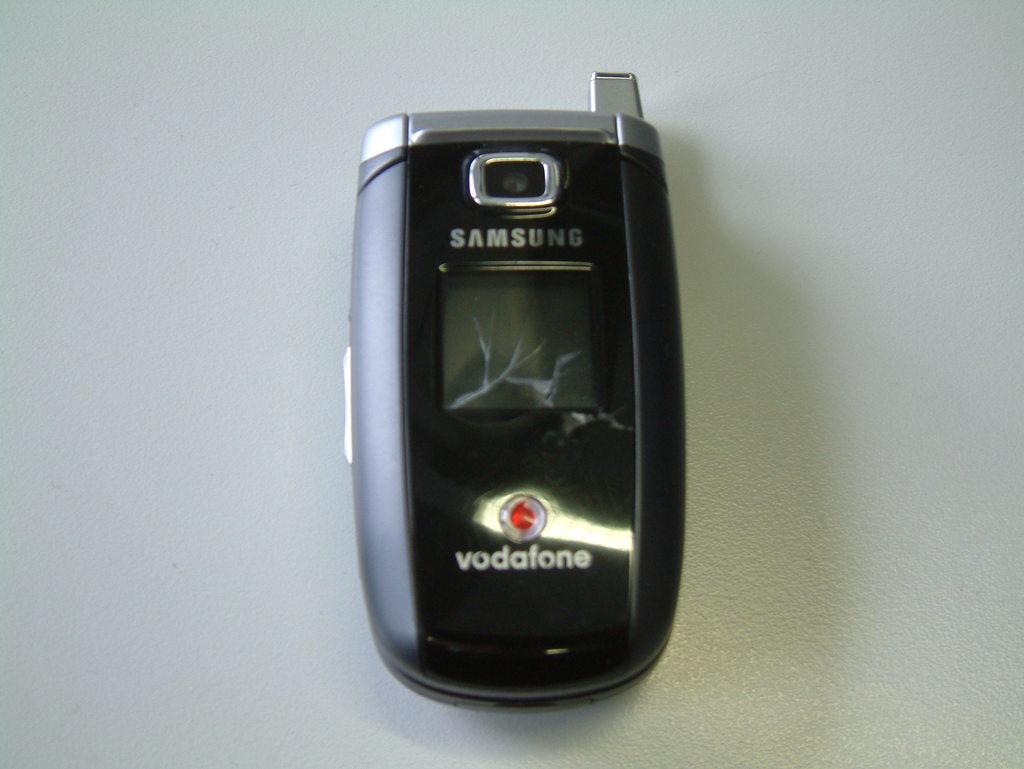What type of gadget is this?
Keep it short and to the point. Samsung. What brand is this phone?
Offer a very short reply. Samsung. 